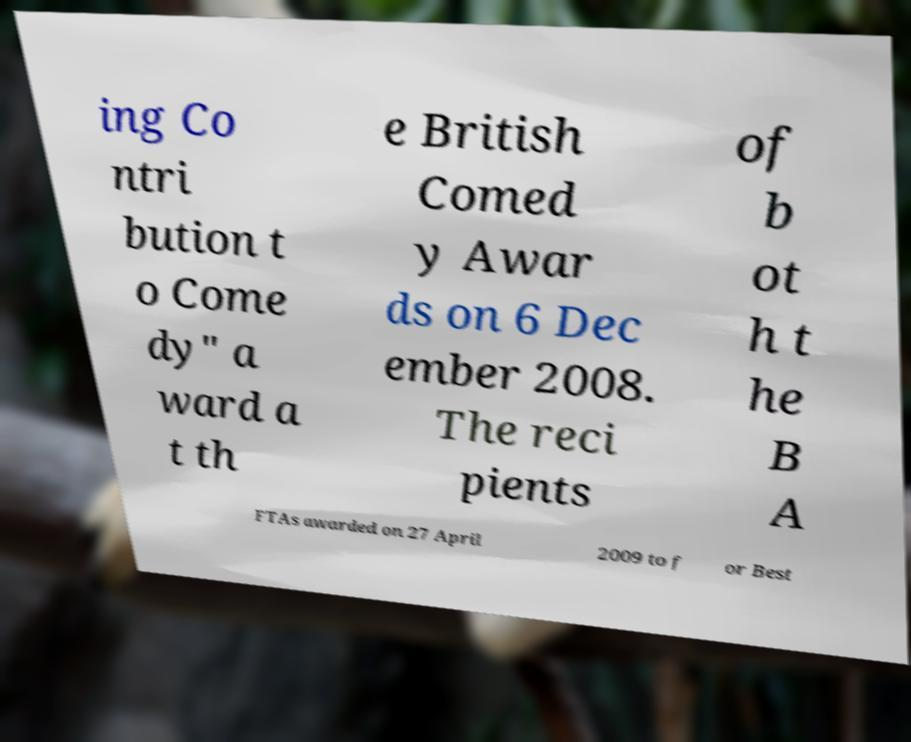Can you read and provide the text displayed in the image?This photo seems to have some interesting text. Can you extract and type it out for me? ing Co ntri bution t o Come dy" a ward a t th e British Comed y Awar ds on 6 Dec ember 2008. The reci pients of b ot h t he B A FTAs awarded on 27 April 2009 to f or Best 